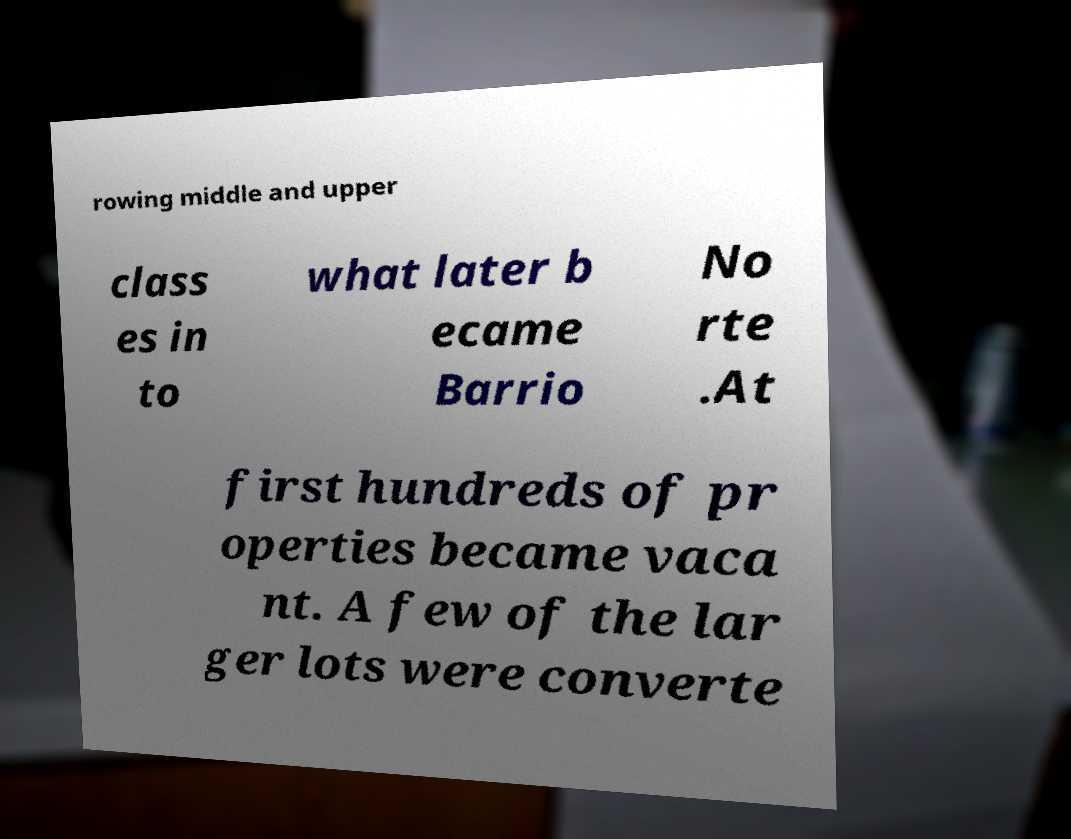Could you extract and type out the text from this image? rowing middle and upper class es in to what later b ecame Barrio No rte .At first hundreds of pr operties became vaca nt. A few of the lar ger lots were converte 